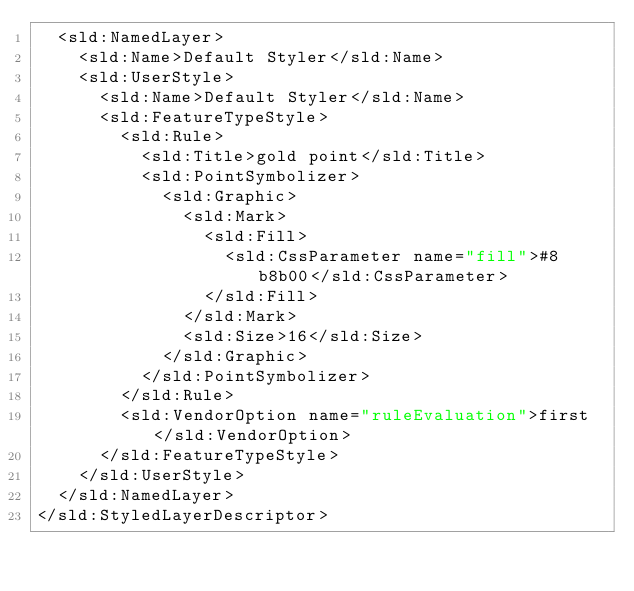Convert code to text. <code><loc_0><loc_0><loc_500><loc_500><_Scheme_>  <sld:NamedLayer>
    <sld:Name>Default Styler</sld:Name>
    <sld:UserStyle>
      <sld:Name>Default Styler</sld:Name>
      <sld:FeatureTypeStyle>
        <sld:Rule>
          <sld:Title>gold point</sld:Title>
          <sld:PointSymbolizer>
            <sld:Graphic>
              <sld:Mark>
                <sld:Fill>
                  <sld:CssParameter name="fill">#8b8b00</sld:CssParameter>
                </sld:Fill>
              </sld:Mark>
              <sld:Size>16</sld:Size>
            </sld:Graphic>
          </sld:PointSymbolizer>
        </sld:Rule>
        <sld:VendorOption name="ruleEvaluation">first</sld:VendorOption>
      </sld:FeatureTypeStyle>
    </sld:UserStyle>
  </sld:NamedLayer>
</sld:StyledLayerDescriptor>

</code> 